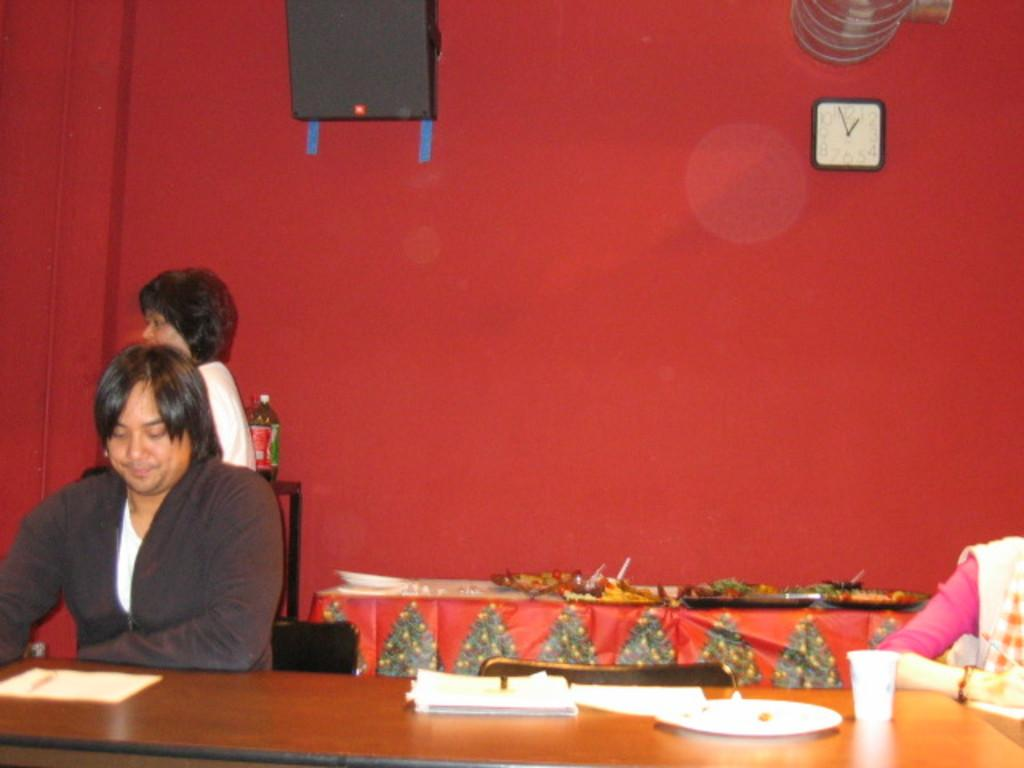Who is present in the image? There is a man in the image. What is the man doing in the image? The man is sitting on a table. Absurd Question/Answer: What type of sponge is the man using to clean the sticks in the town? There is no sponge, sticks, or town present in the image. The conversation focuses on the man and his action of sitting on a table. We create questions that can be answered definitively based on the provided facts, avoiding yes/no questions and ensuring simple and clear language. Absurd Question/Answer: What type of town is visible in the background of the image? There is no town visible in the background of the image. 